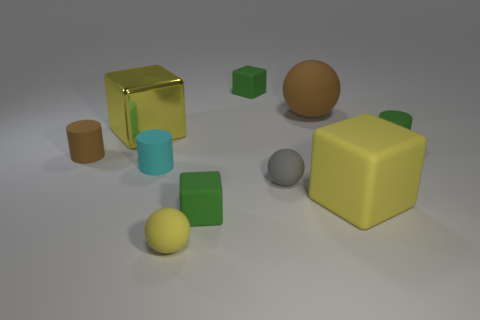What number of other things are there of the same shape as the cyan thing?
Keep it short and to the point. 2. Does the small rubber block behind the large yellow shiny cube have the same color as the matte ball in front of the tiny gray rubber ball?
Provide a short and direct response. No. There is a brown rubber thing that is on the left side of the tiny sphere left of the small green rubber block in front of the cyan rubber cylinder; how big is it?
Make the answer very short. Small. There is a rubber object that is in front of the cyan cylinder and right of the gray sphere; what is its shape?
Your answer should be compact. Cube. Are there the same number of large blocks that are to the left of the yellow matte sphere and rubber blocks that are left of the yellow rubber cube?
Offer a terse response. No. Is there a small blue thing made of the same material as the brown cylinder?
Provide a short and direct response. No. Does the small cube that is in front of the small brown object have the same material as the small brown object?
Provide a succinct answer. Yes. What size is the matte sphere that is both behind the small yellow thing and in front of the tiny cyan cylinder?
Give a very brief answer. Small. The large metal block is what color?
Keep it short and to the point. Yellow. How many cubes are there?
Keep it short and to the point. 4. 